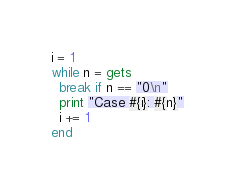<code> <loc_0><loc_0><loc_500><loc_500><_Ruby_>i = 1
while n = gets
  break if n == "0\n"
  print "Case #{i}: #{n}"
  i += 1
end</code> 